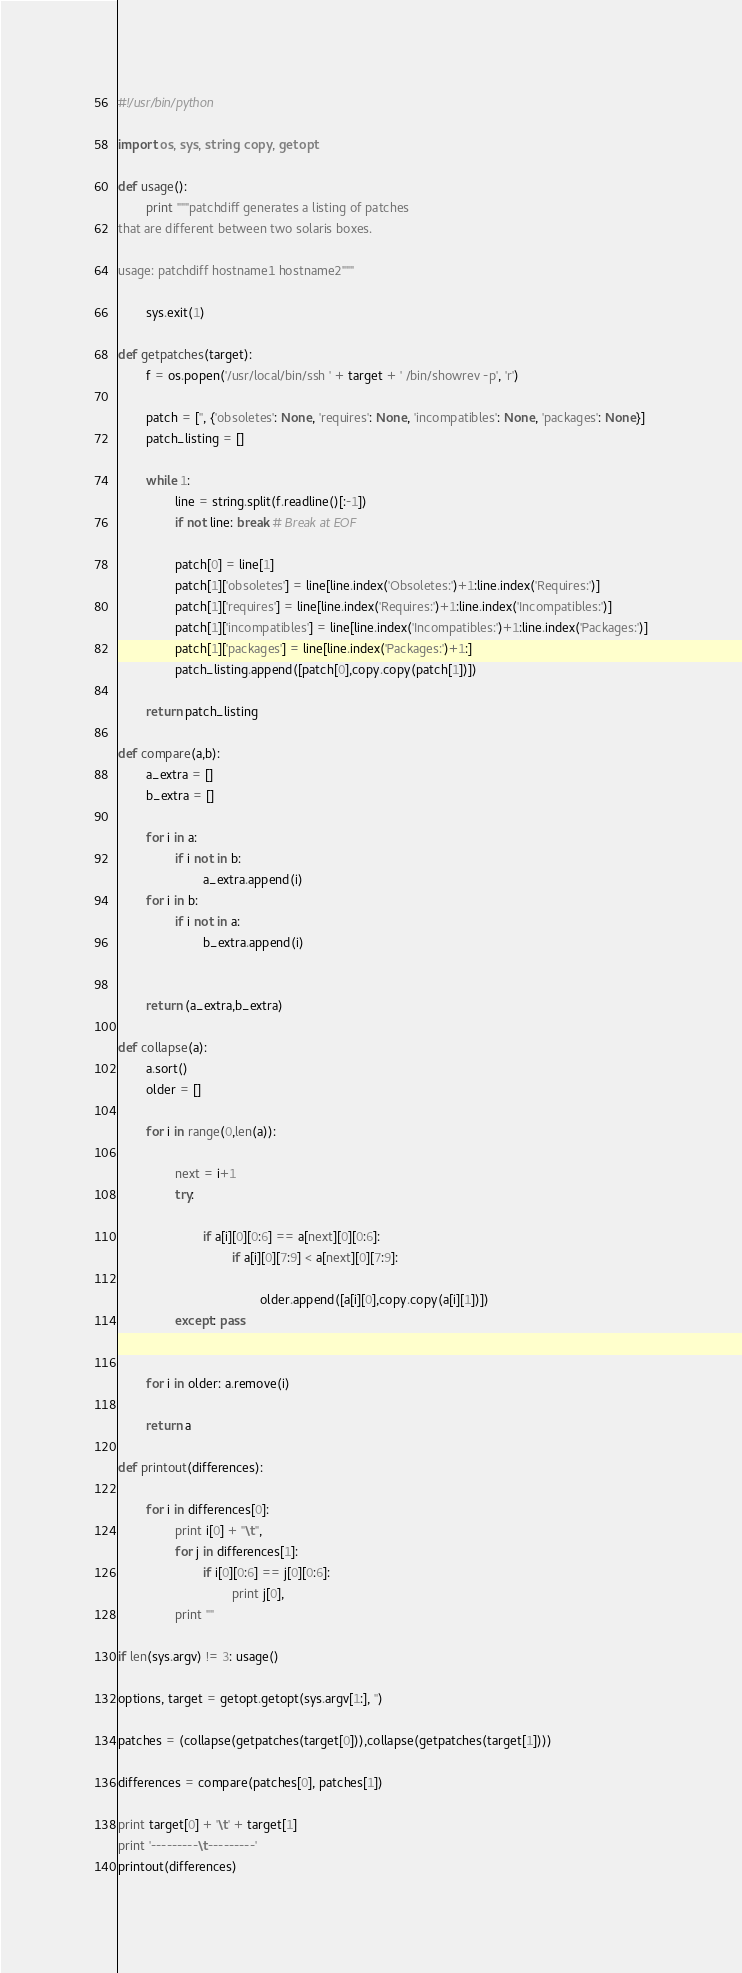Convert code to text. <code><loc_0><loc_0><loc_500><loc_500><_Python_>#!/usr/bin/python

import os, sys, string, copy, getopt

def usage():
        print """patchdiff generates a listing of patches
that are different between two solaris boxes.

usage: patchdiff hostname1 hostname2"""

        sys.exit(1)

def getpatches(target):
        f = os.popen('/usr/local/bin/ssh ' + target + ' /bin/showrev -p', 'r')

        patch = ['', {'obsoletes': None, 'requires': None, 'incompatibles': None, 'packages': None}]
        patch_listing = []

        while 1:
                line = string.split(f.readline()[:-1])
                if not line: break # Break at EOF

                patch[0] = line[1]
                patch[1]['obsoletes'] = line[line.index('Obsoletes:')+1:line.index('Requires:')]
                patch[1]['requires'] = line[line.index('Requires:')+1:line.index('Incompatibles:')]
                patch[1]['incompatibles'] = line[line.index('Incompatibles:')+1:line.index('Packages:')]
                patch[1]['packages'] = line[line.index('Packages:')+1:]
                patch_listing.append([patch[0],copy.copy(patch[1])])

        return patch_listing

def compare(a,b):
        a_extra = []
        b_extra = []

        for i in a:
                if i not in b:
                        a_extra.append(i)
        for i in b:
                if i not in a:
                        b_extra.append(i)


        return (a_extra,b_extra)

def collapse(a):
        a.sort()
        older = []

        for i in range(0,len(a)):

                next = i+1
                try:

                        if a[i][0][0:6] == a[next][0][0:6]:
                                if a[i][0][7:9] < a[next][0][7:9]:

                                        older.append([a[i][0],copy.copy(a[i][1])])
                except: pass


        for i in older: a.remove(i)

        return a

def printout(differences):

        for i in differences[0]:
                print i[0] + "\t",
                for j in differences[1]:
                        if i[0][0:6] == j[0][0:6]:
                                print j[0],
                print ""

if len(sys.argv) != 3: usage()

options, target = getopt.getopt(sys.argv[1:], '')

patches = (collapse(getpatches(target[0])),collapse(getpatches(target[1])))

differences = compare(patches[0], patches[1])

print target[0] + '\t' + target[1]
print '---------\t---------'
printout(differences)
</code> 